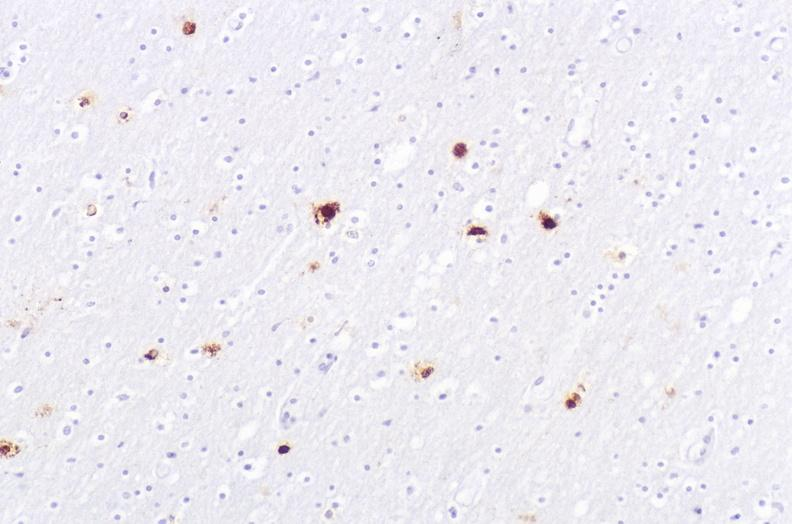what does this image show?
Answer the question using a single word or phrase. Herpes simplex virus 